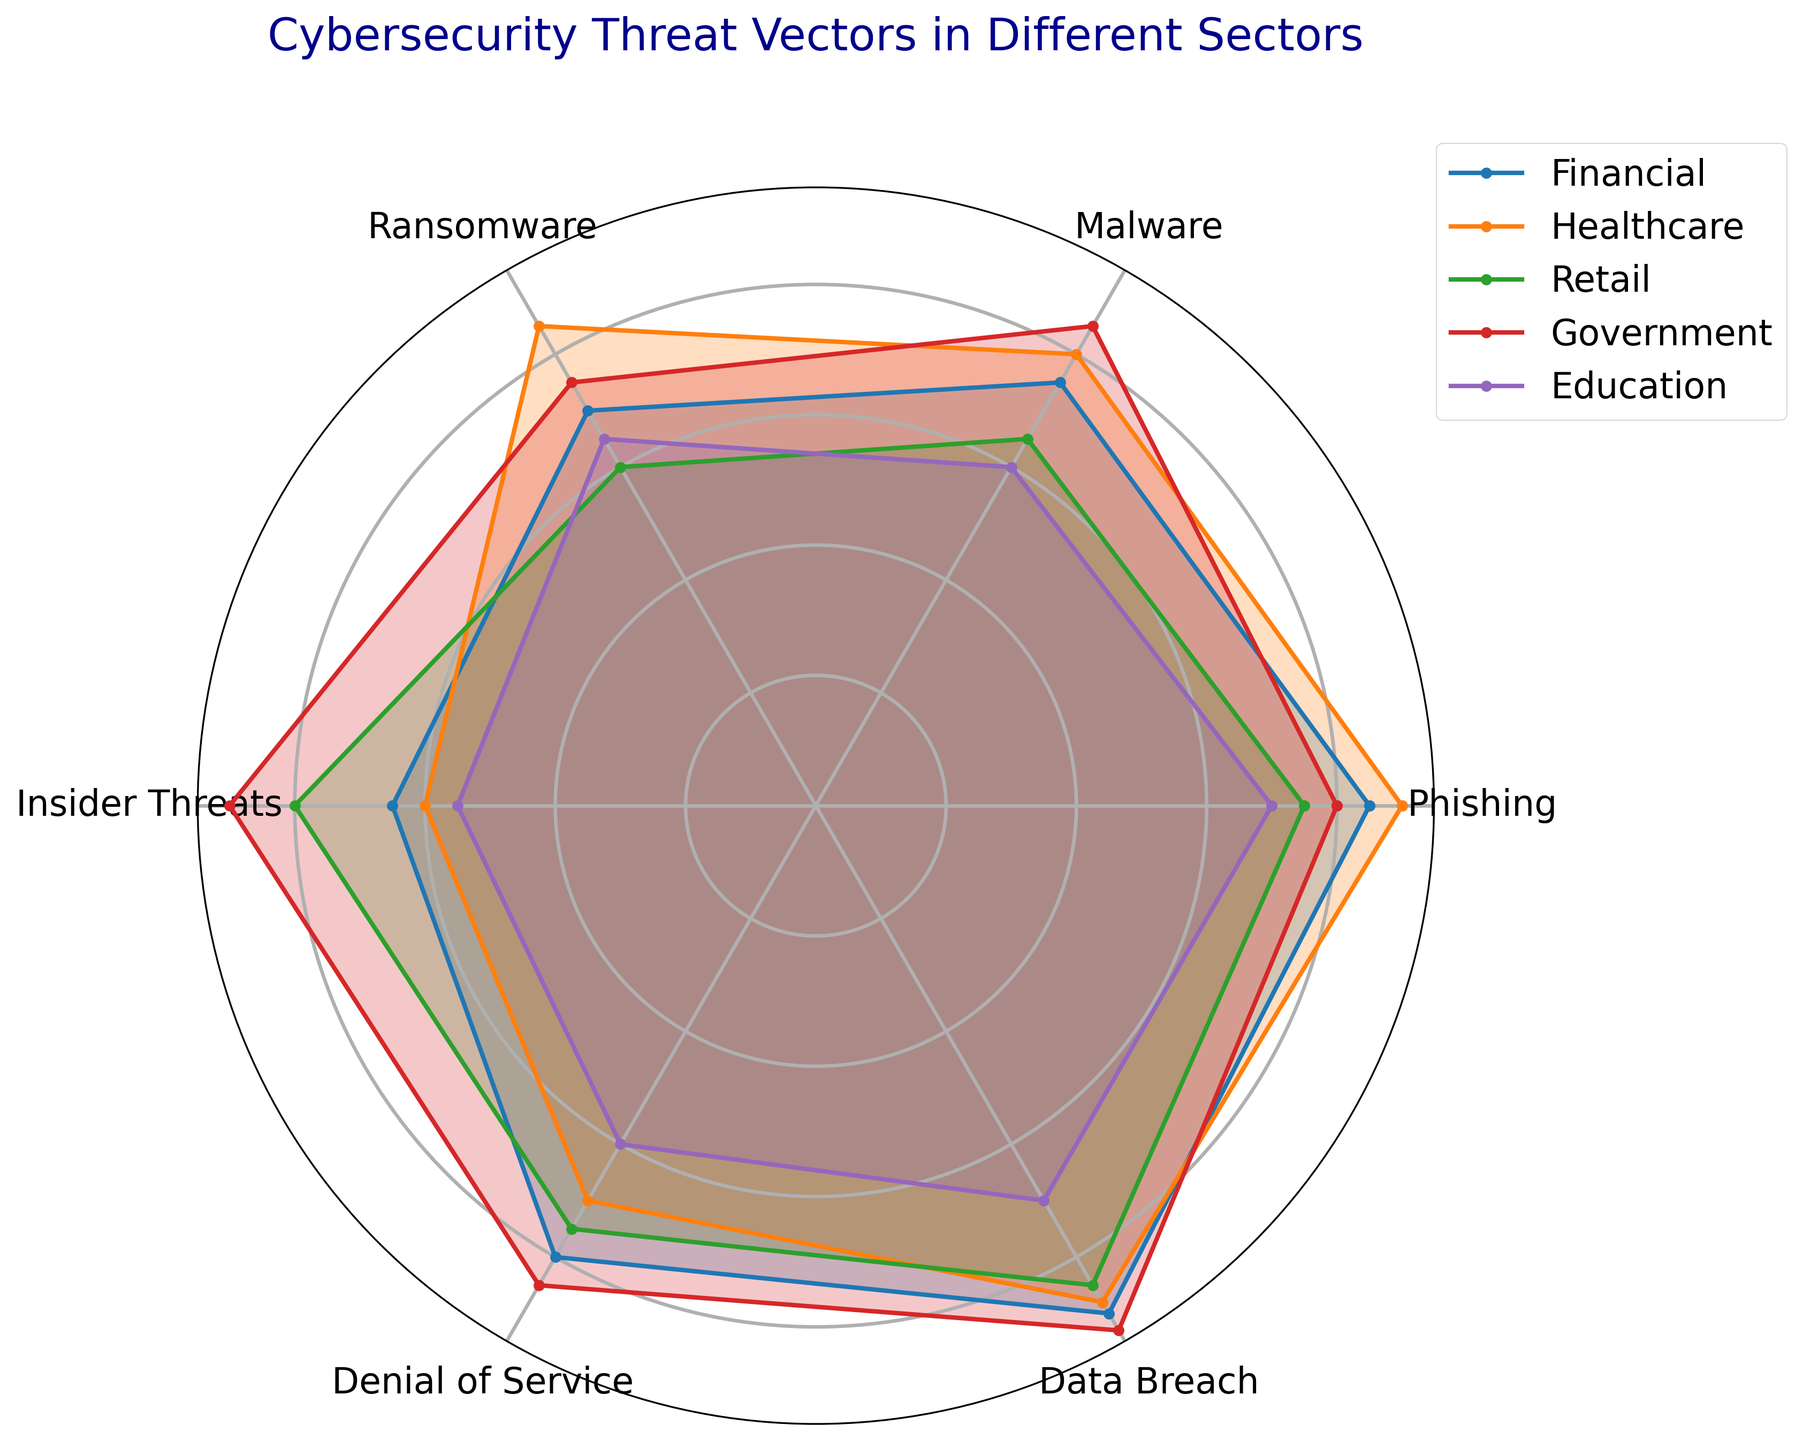Which sector has the highest threat level for Insider Threats? First, identify the section of the radar chart labeled "Insider Threats". Then, look at which sector's plot point is furthest away from the center (highest value) on this axis. The sector with the highest value for Insider Threats is "Government" with a score closest to the edge.
Answer: Government Which sector has the lowest average threat level across all vectors? Calculate the average threat level for each sector by summing the values for all threat vectors and dividing by 6. Compare these averages to find the lowest one. The calculations show "Education" has the lowest average: (70 + 60 + 65 + 55 + 60 + 70) / 6 = 63.33, which is the lowest compared to the other sectors.
Answer: Education Which two sectors are most vulnerable to Data Breach threats? Identify the section of the radar chart labeled "Data Breach". Then, look at which two sectors have plot points furthest away from the center on this axis. These are the sectors with the highest values for Data Breach. "Government" and "Financial" are the two sectors with the top values at 93 and 90 respectively.
Answer: Government and Financial How does the threat level for Ransomware in the Retail sector compare to that in the Financial sector? Locate the "Ransomware" axis on the chart and then compare the values for "Retail" and "Financial" sectors. The Retail sector has a value of 60, whereas the Financial sector has a value of 70. Thus, the Financial sector has a higher threat level for Ransomware compared to Retail.
Answer: Financial > Retail What is the difference in the threat level of Phishing between Healthcare and Education sectors? Find the "Phishing" axis on the chart and note the values for "Healthcare" and "Education" sectors. Healthcare has a value of 90 and Education has a value of 70. Subtract the lower value from the higher value to find the difference: 90 - 70 = 20.
Answer: 20 Which sector appears to be the least at risk from Denial of Service attacks? Identify the "Denial of Service" axis on the chart and look at which sector's plot point is closest to the center (lowest value). The sector with the lowest value is "Education" with a score of 60.
Answer: Education Rank the sectors in order of vulnerability to Malware from highest to lowest. On the "Malware" axis, compare the values for each sector and arrange them in descending order. The values are: Government (85), Healthcare (80), Financial (75), Retail (65), Education (60). Thus, the order is: Government, Healthcare, Financial, Retail, Education.
Answer: Government, Healthcare, Financial, Retail, Education Which sector has the most balanced threat profile across all vectors? A balanced threat profile would have similar values across all threat vectors. Observe the radar chart and check for the sector whose plot forms the most regular, near-circle shape. "Financial" appears to have a relatively balanced threat profile as its values are more evenly distributed compared to the others.
Answer: Financial 